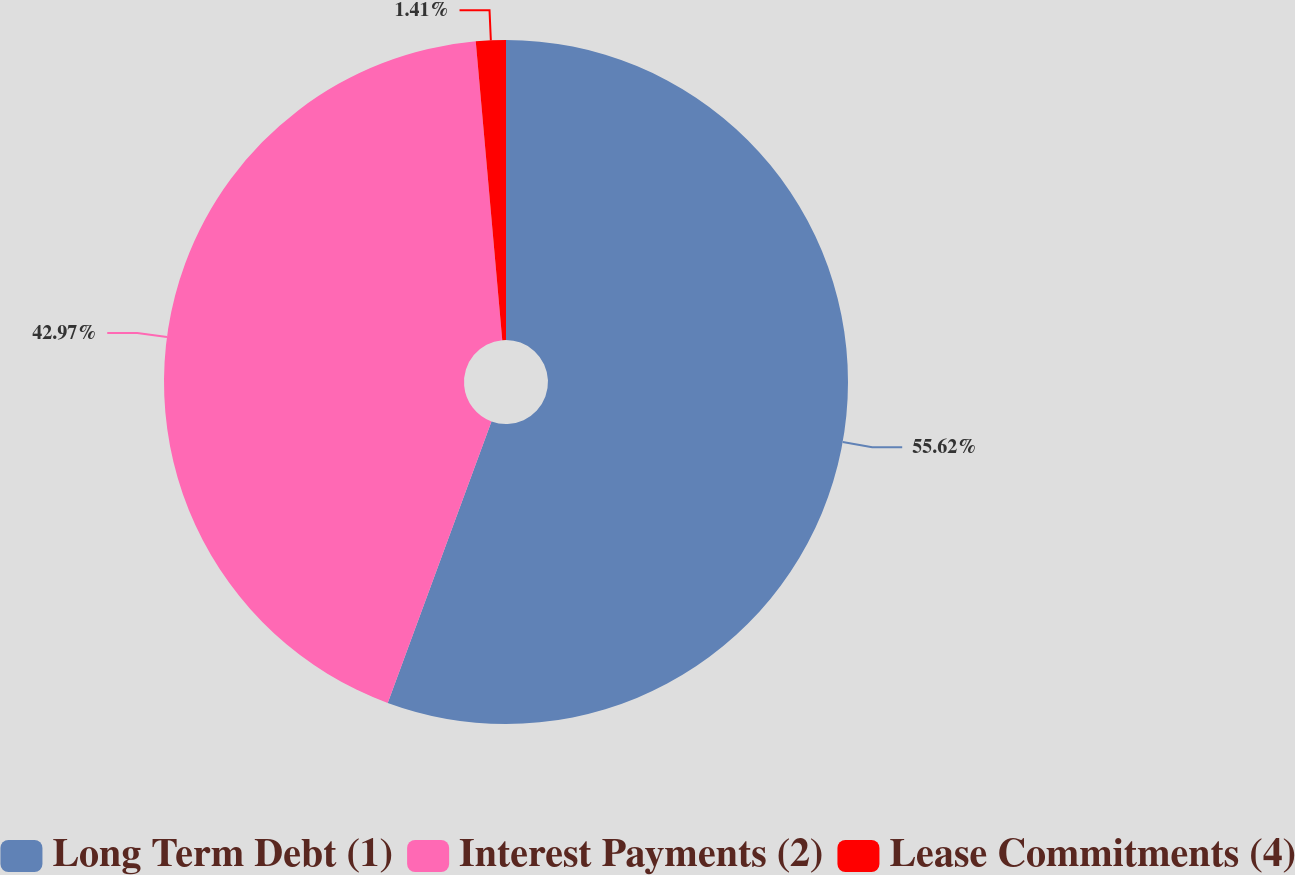Convert chart. <chart><loc_0><loc_0><loc_500><loc_500><pie_chart><fcel>Long Term Debt (1)<fcel>Interest Payments (2)<fcel>Lease Commitments (4)<nl><fcel>55.62%<fcel>42.97%<fcel>1.41%<nl></chart> 